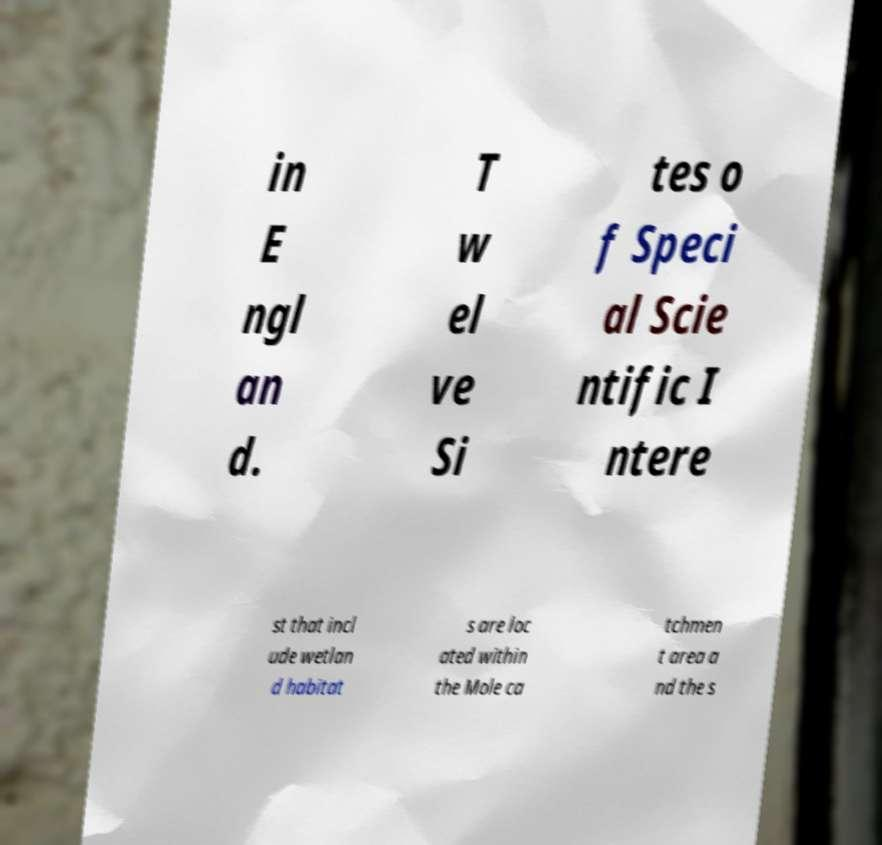Can you accurately transcribe the text from the provided image for me? in E ngl an d. T w el ve Si tes o f Speci al Scie ntific I ntere st that incl ude wetlan d habitat s are loc ated within the Mole ca tchmen t area a nd the s 